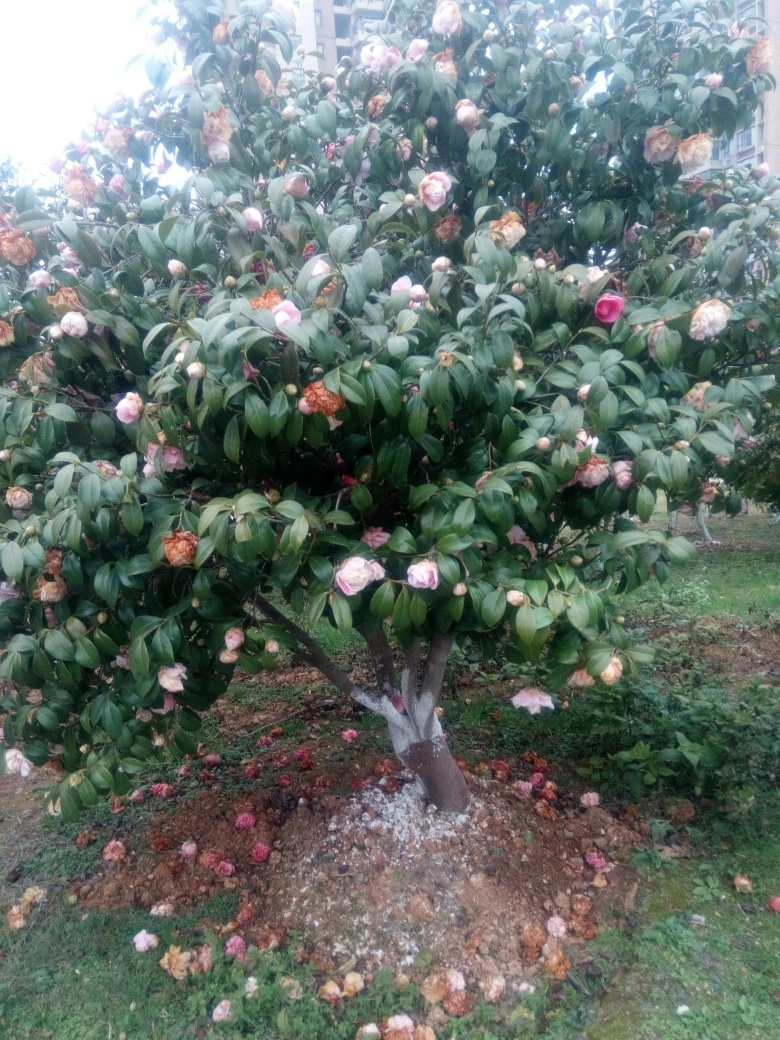What does the base of the tree indicate about the care it's receiving? The base of the tree is covered with a layer of mulch, and despite some fallen leaves and petals, the soil looks relatively clear of weeds. This suggests that the tree has been tended to and is receiving care to maintain its health and appearance. 